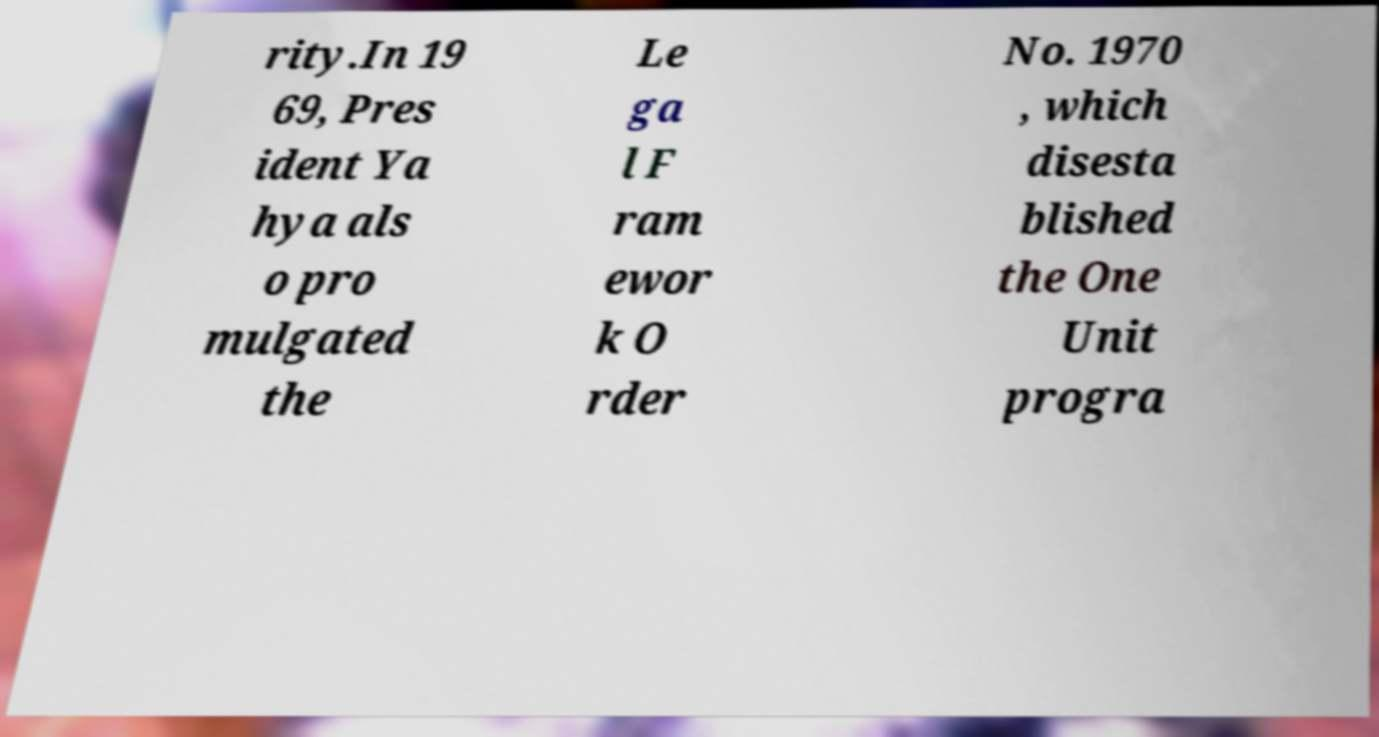Could you extract and type out the text from this image? rity.In 19 69, Pres ident Ya hya als o pro mulgated the Le ga l F ram ewor k O rder No. 1970 , which disesta blished the One Unit progra 